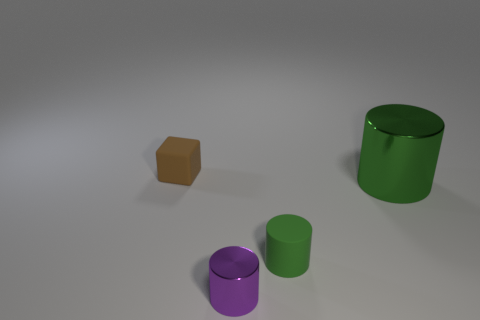How many other objects are the same color as the small matte cylinder?
Your response must be concise. 1. Is the small purple object that is to the left of the big cylinder made of the same material as the small green thing?
Offer a very short reply. No. Are there fewer tiny green rubber cylinders that are in front of the tiny green rubber cylinder than green cylinders right of the large thing?
Your answer should be compact. No. How many other objects are the same material as the large green object?
Your response must be concise. 1. What material is the cube that is the same size as the purple shiny object?
Offer a very short reply. Rubber. Is the number of purple things that are on the left side of the small brown matte thing less than the number of large brown shiny objects?
Keep it short and to the point. No. There is a metal object that is behind the object that is in front of the rubber object that is in front of the small brown matte thing; what is its shape?
Ensure brevity in your answer.  Cylinder. How big is the matte thing right of the small brown matte thing?
Keep it short and to the point. Small. There is a metallic object that is the same size as the green matte object; what shape is it?
Offer a very short reply. Cylinder. What number of things are either yellow metal cylinders or green objects behind the small matte cylinder?
Give a very brief answer. 1. 